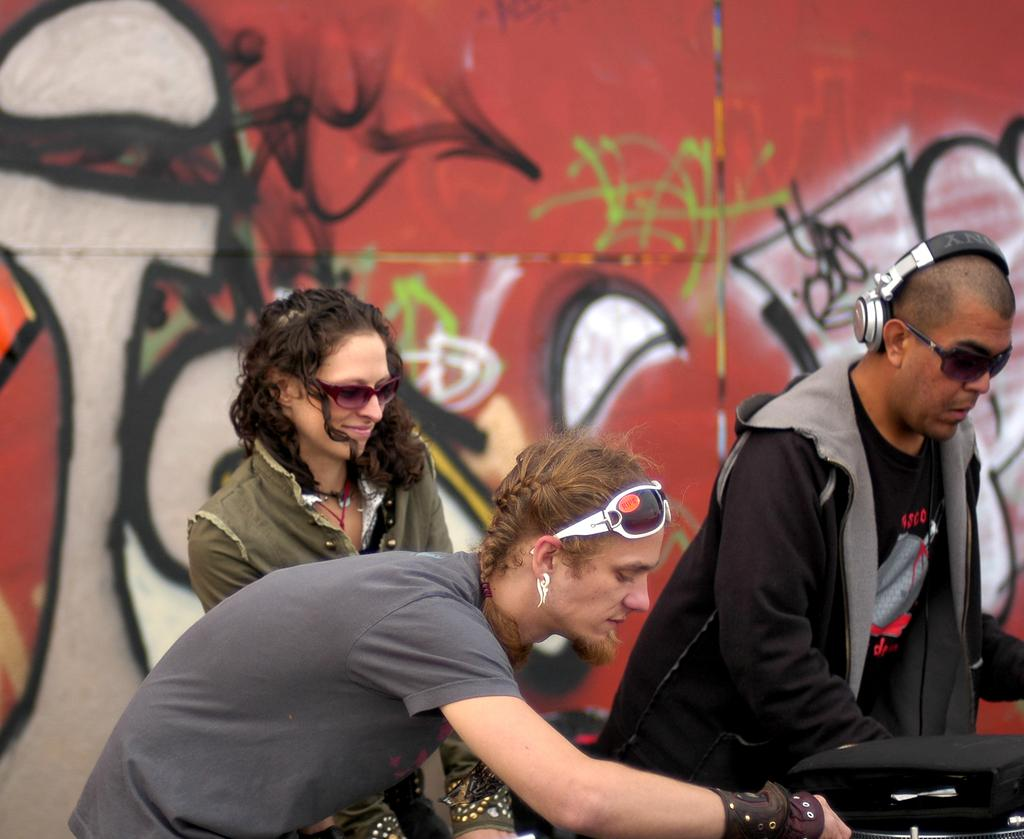Who or what can be seen in the front of the image? There are people in the front of the image. How are the people positioned in the image? The people are scattered throughout the image. What can be seen in the background of the image? There is a building in the background of the image. What type of advice can be seen being given in the image? There is no advice being given in the image; it features people and a building in the background. 